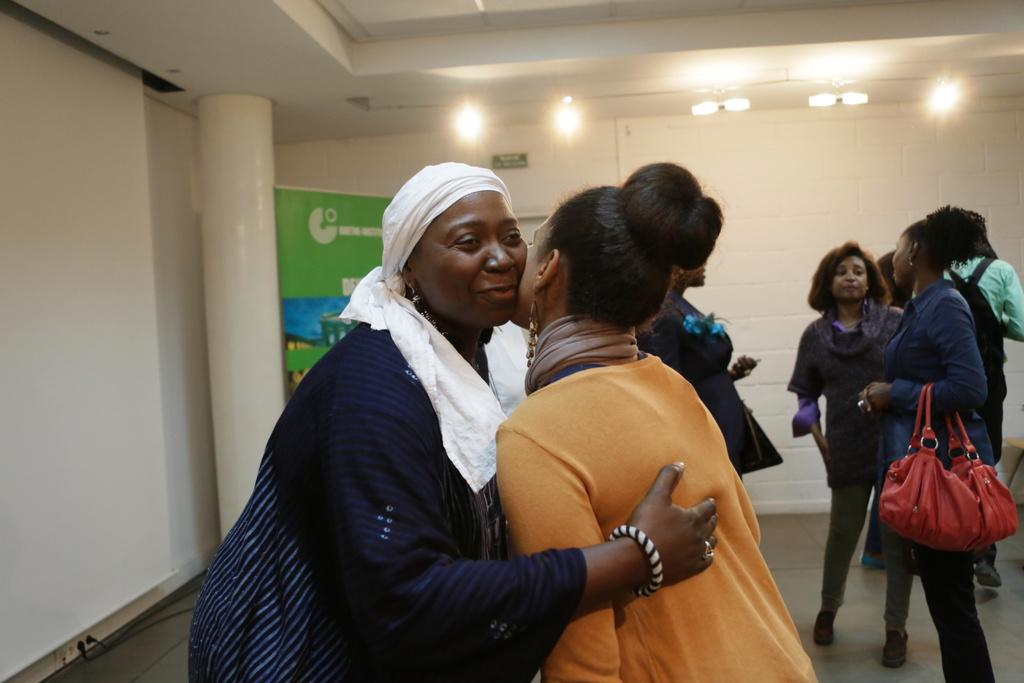What type of structure can be seen in the image? There is a wall in the image. What is hanging on the wall? There is a banner in the image. Are there any people present in the image? Yes, there are people standing in the image. How many books are stacked on the tent in the image? There are no books or tents present in the image. 